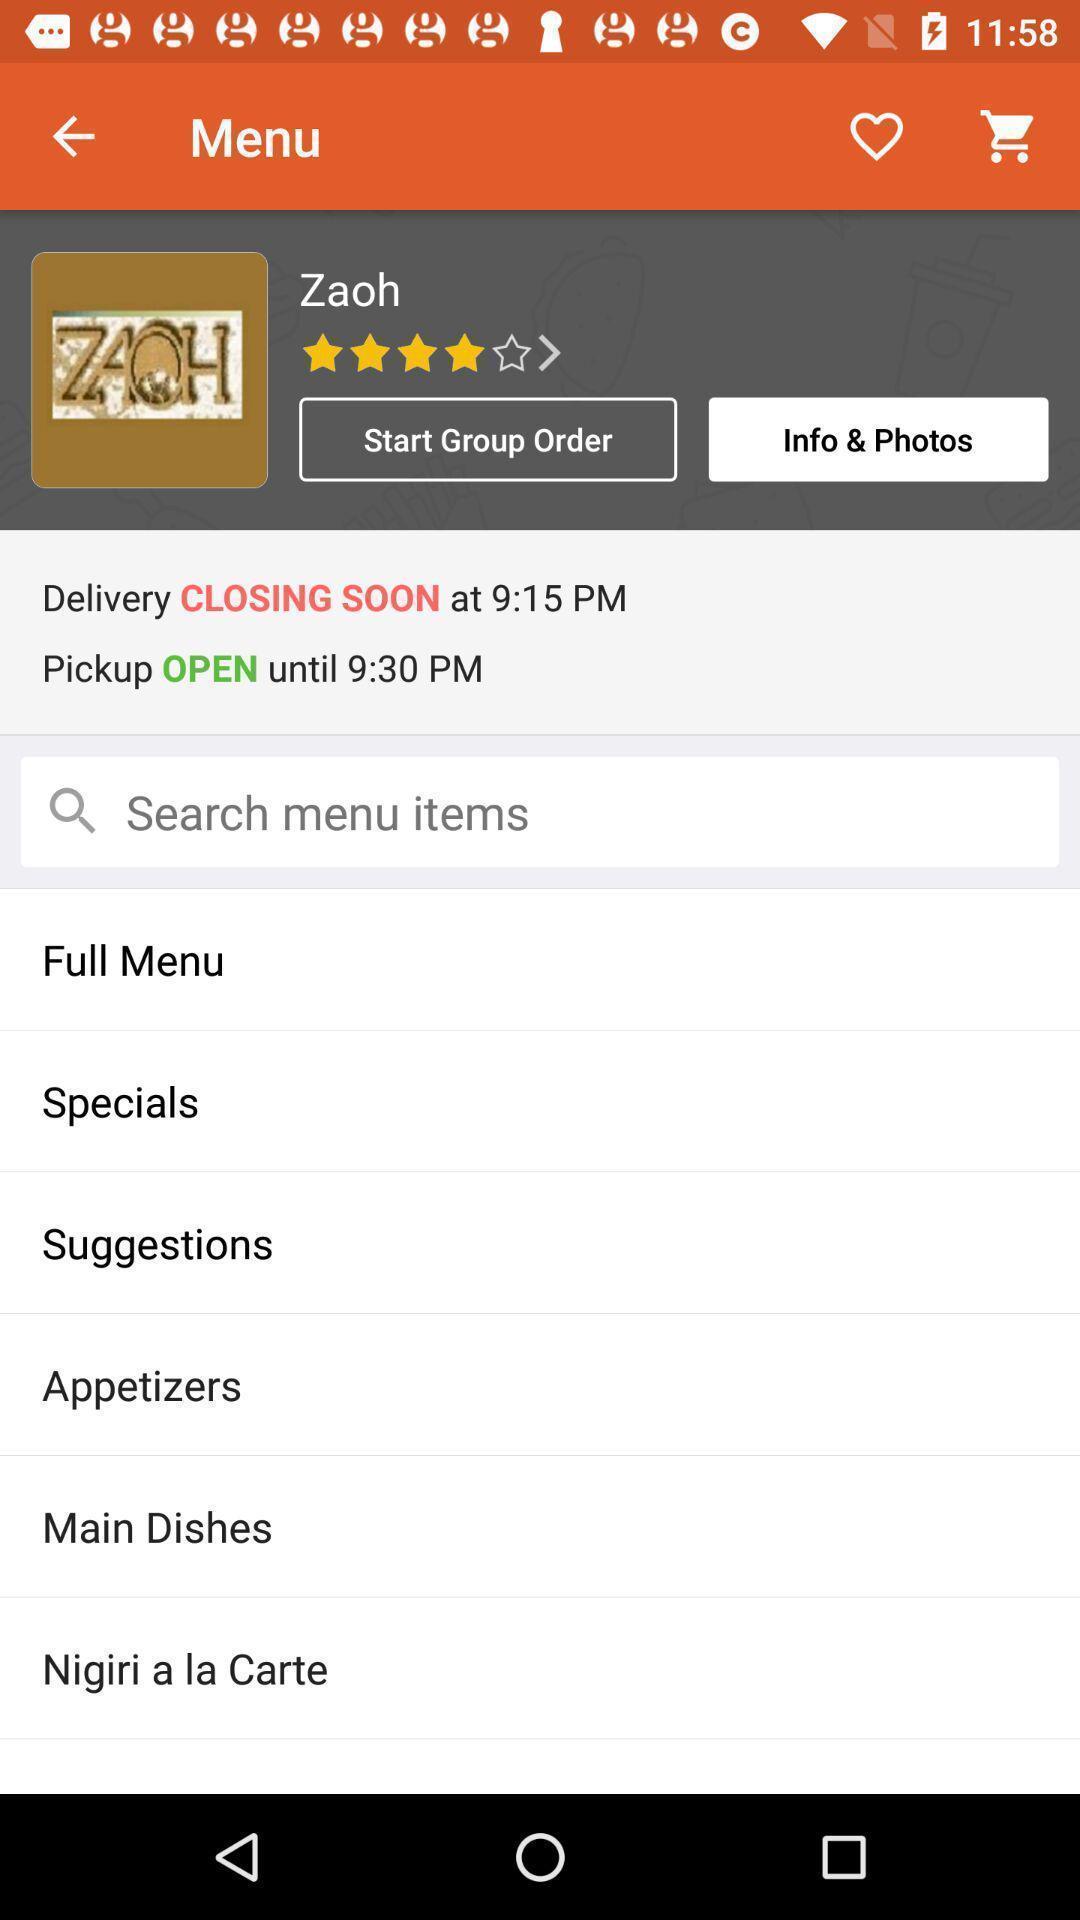Describe the key features of this screenshot. Search bar to search for the menu. 